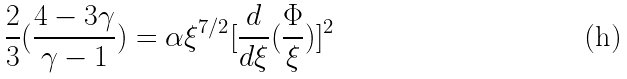<formula> <loc_0><loc_0><loc_500><loc_500>\frac { 2 } { 3 } ( \frac { 4 - 3 \gamma } { \gamma - 1 } ) = \alpha \xi ^ { 7 / 2 } [ \frac { d } { d \xi } ( \frac { \Phi } { \xi } ) ] ^ { 2 }</formula> 